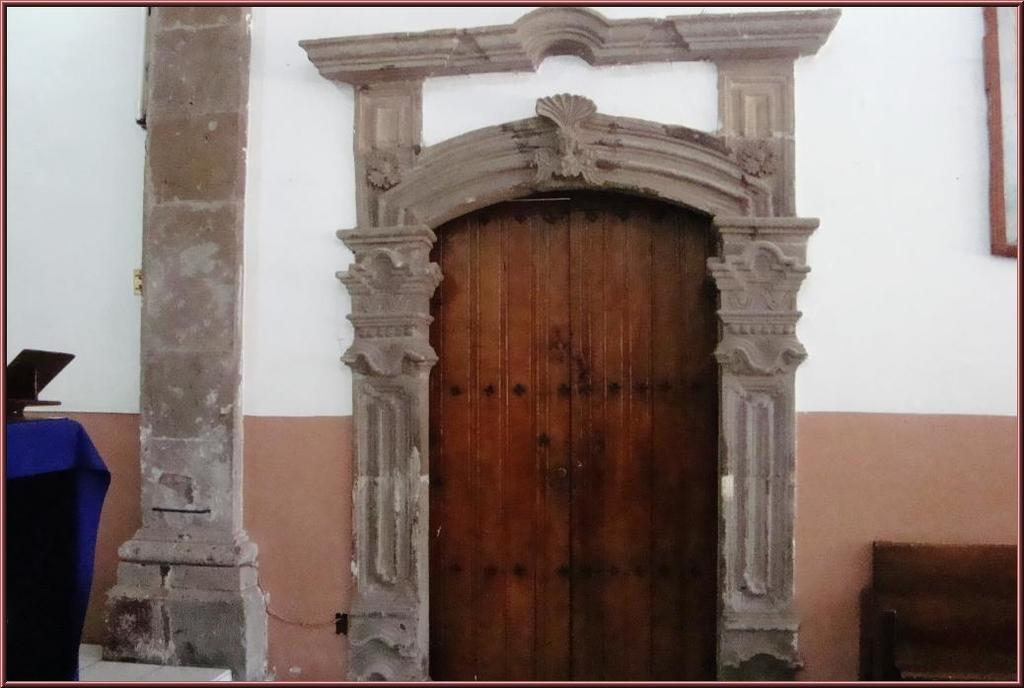What is the color and material of the door in the image? The door in the image is a brown color wooden door. What colors are present on the wall in the image? The wall in the image is white and brown in color. Can you describe the object on the blue cloth in the image? There is a black color object on a blue color cloth in the image. How many brothers are visible in the image? There are no brothers present in the image. Can you describe the eye color of the person in the image? There is no person present in the image, so it is not possible to determine their eye color. 